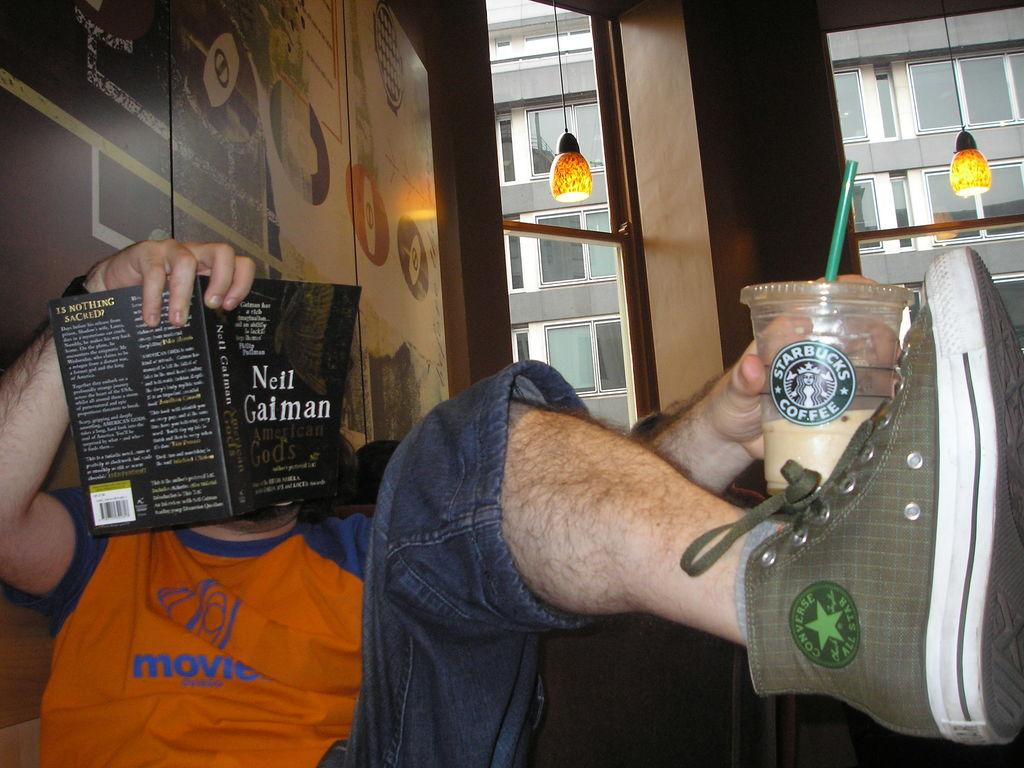<image>
Offer a succinct explanation of the picture presented. A man in a coffee shop reading the book American Gods by Neil Gaiman. 